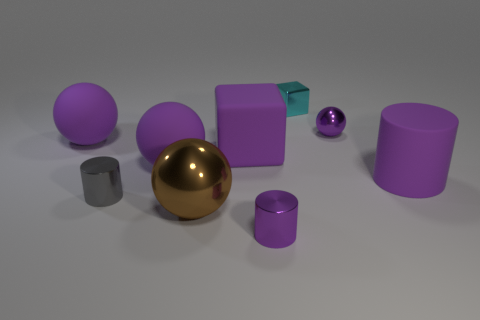Subtract all gray cylinders. How many purple balls are left? 3 Subtract all red balls. Subtract all gray cubes. How many balls are left? 4 Add 1 small brown metallic cylinders. How many objects exist? 10 Subtract all cubes. How many objects are left? 7 Subtract all green metal blocks. Subtract all cyan objects. How many objects are left? 8 Add 8 big purple matte cubes. How many big purple matte cubes are left? 9 Add 2 tiny blue cylinders. How many tiny blue cylinders exist? 2 Subtract 0 red cylinders. How many objects are left? 9 